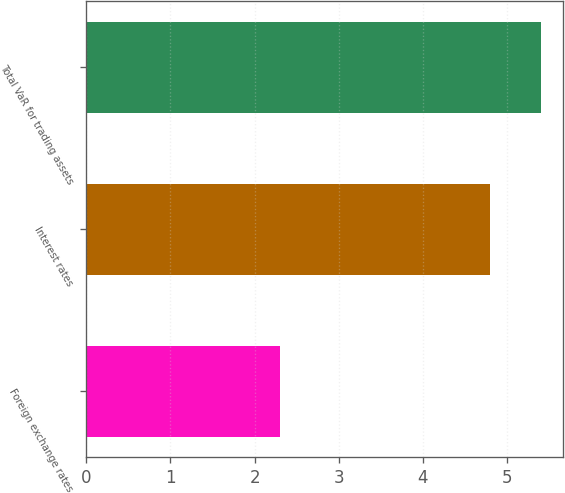<chart> <loc_0><loc_0><loc_500><loc_500><bar_chart><fcel>Foreign exchange rates<fcel>Interest rates<fcel>Total VaR for trading assets<nl><fcel>2.3<fcel>4.8<fcel>5.4<nl></chart> 